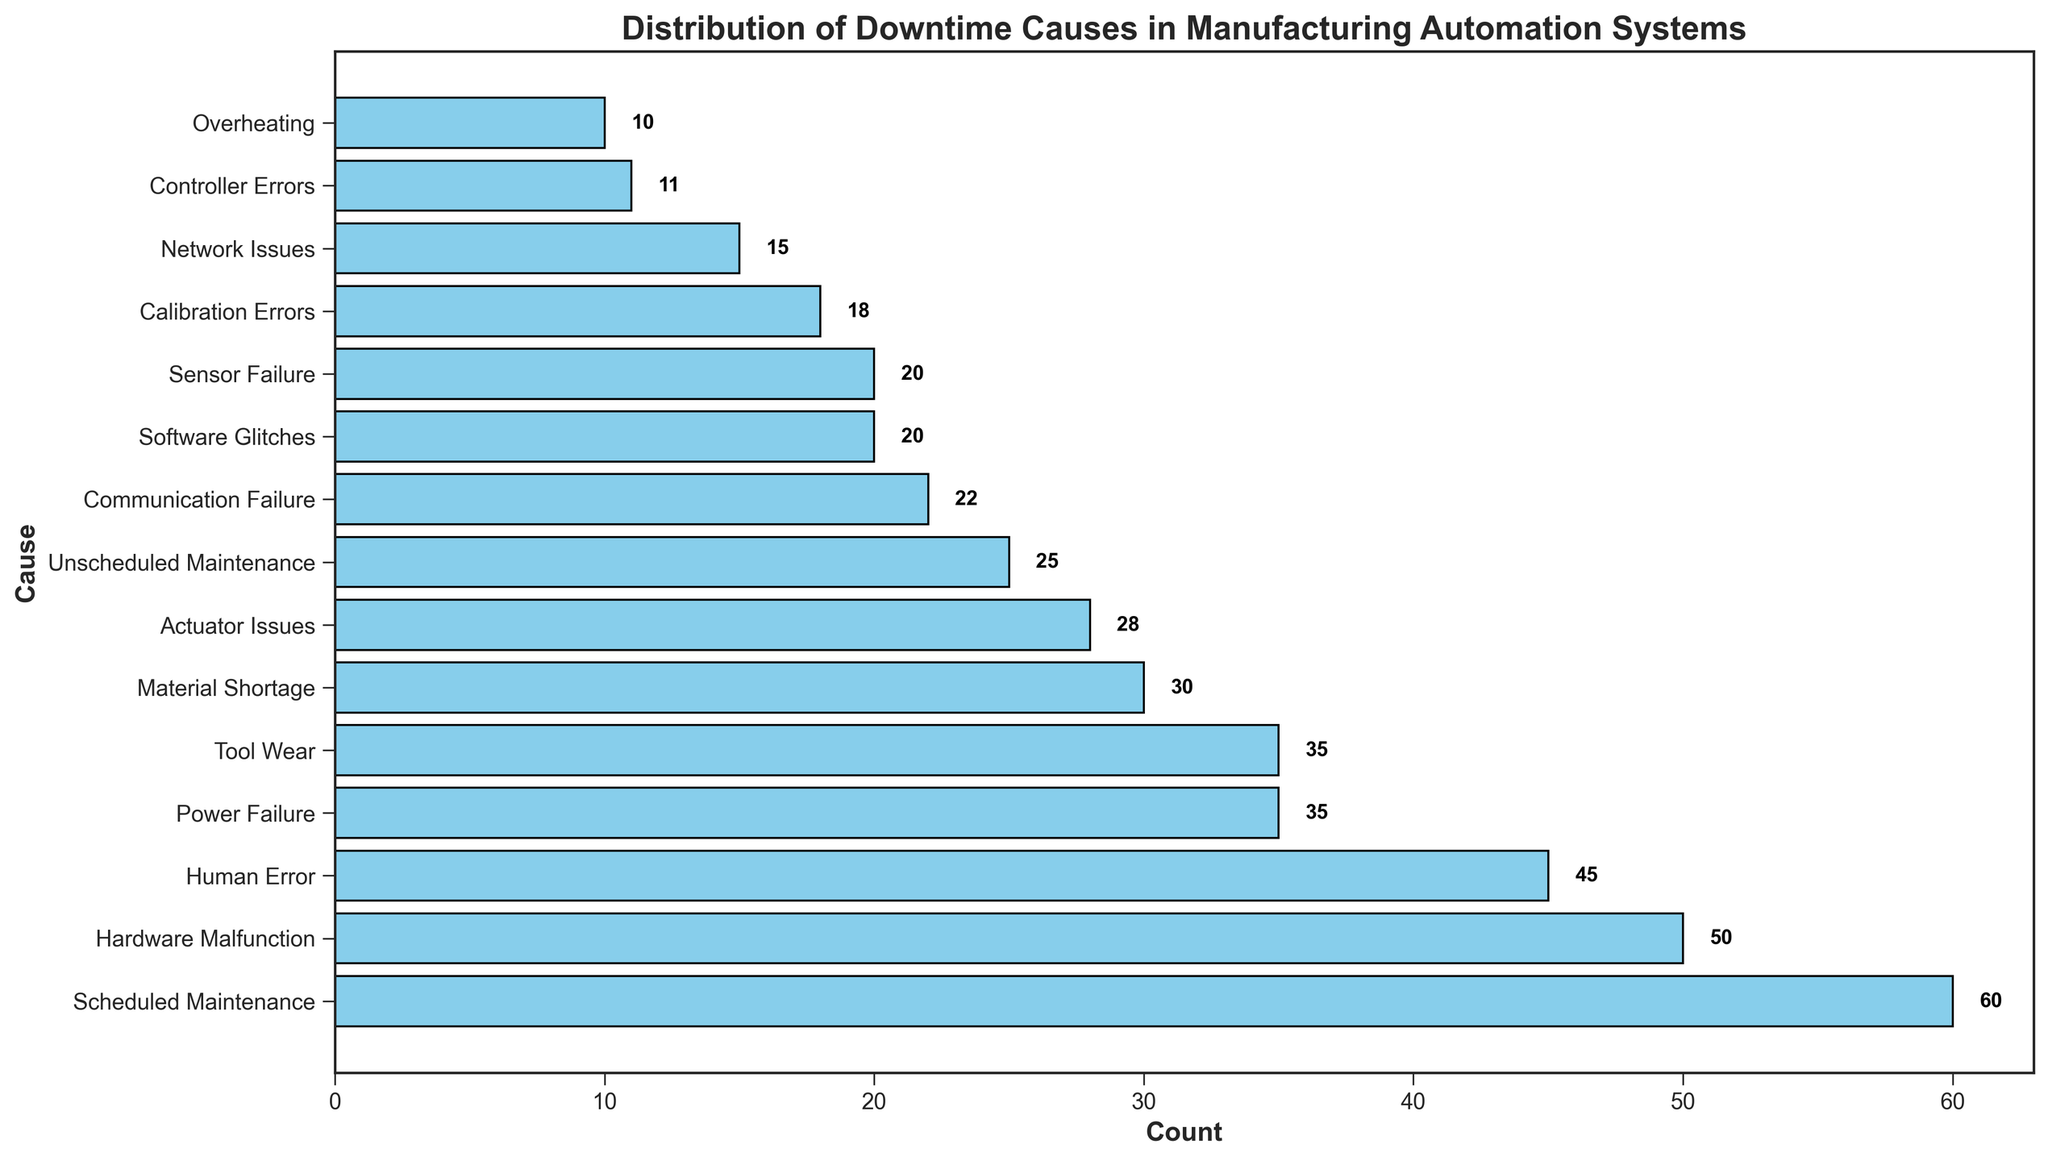Which cause has the highest count of downtime occurrences? From the figure, the highest bar represents the cause with the highest count. This bar is labeled "Scheduled Maintenance" with a count of 60.
Answer: Scheduled Maintenance Which cause has the lowest count of downtime occurrences? The smallest bar in the figure represents the cause with the lowest count, which is labeled "Overheating" with a count of 10.
Answer: Overheating What is the total count of downtime occurrences caused by "Power Failure" and "Human Error"? From the figure, identify the bars labeled "Power Failure" and "Human Error," which have counts of 35 and 45 respectively. Adding these gives 35 + 45 = 80.
Answer: 80 How much greater is the count of "Hardware Malfunction" compared to "Network Issues"? Identify the counts for "Hardware Malfunction" and "Network Issues," which are 50 and 15 respectively. Subtract the lesser count from the greater count: 50 - 15 = 35.
Answer: 35 Which cause of downtime is twice as frequent, "Material Shortage" or "Sensor Failure"? From the figure, "Material Shortage" has a count of 30, and "Sensor Failure" has a count of 20. Twice the count of "Sensor Failure" is 40, which is greater than 30, so neither is twice as frequent as the other.
Answer: Neither What is the average count of downtime occurrences from "Software Glitches," "Sensor Failure," and "Tool Wear"? Retrieve the counts for these causes: Software Glitches (20), Sensor Failure (20), and Tool Wear (35). Calculate the average: (20 + 20 + 35) / 3 = 75 / 3 = 25.
Answer: 25 Compare the counts of "Calibration Errors" and "Actuator Issues." Which cause has a higher count and by how much? Identify the counts for "Calibration Errors" (18) and "Actuator Issues" (28). "Actuator Issues" is higher by 28 - 18 = 10.
Answer: Actuator Issues by 10 